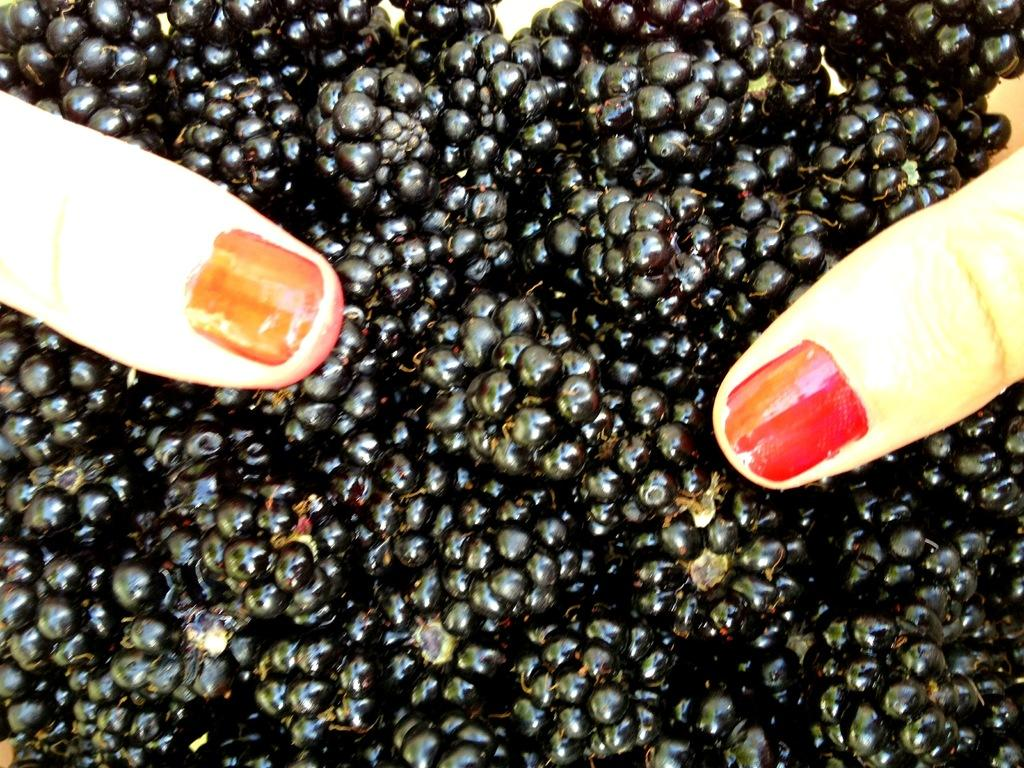What type of fruit is present in the image? There are black berries in the image. What body part is visible in the image? Human fingers are visible in the image. What is the acoustics like in the image? There is no information about the acoustics in the image, as it only features black berries and human fingers. 